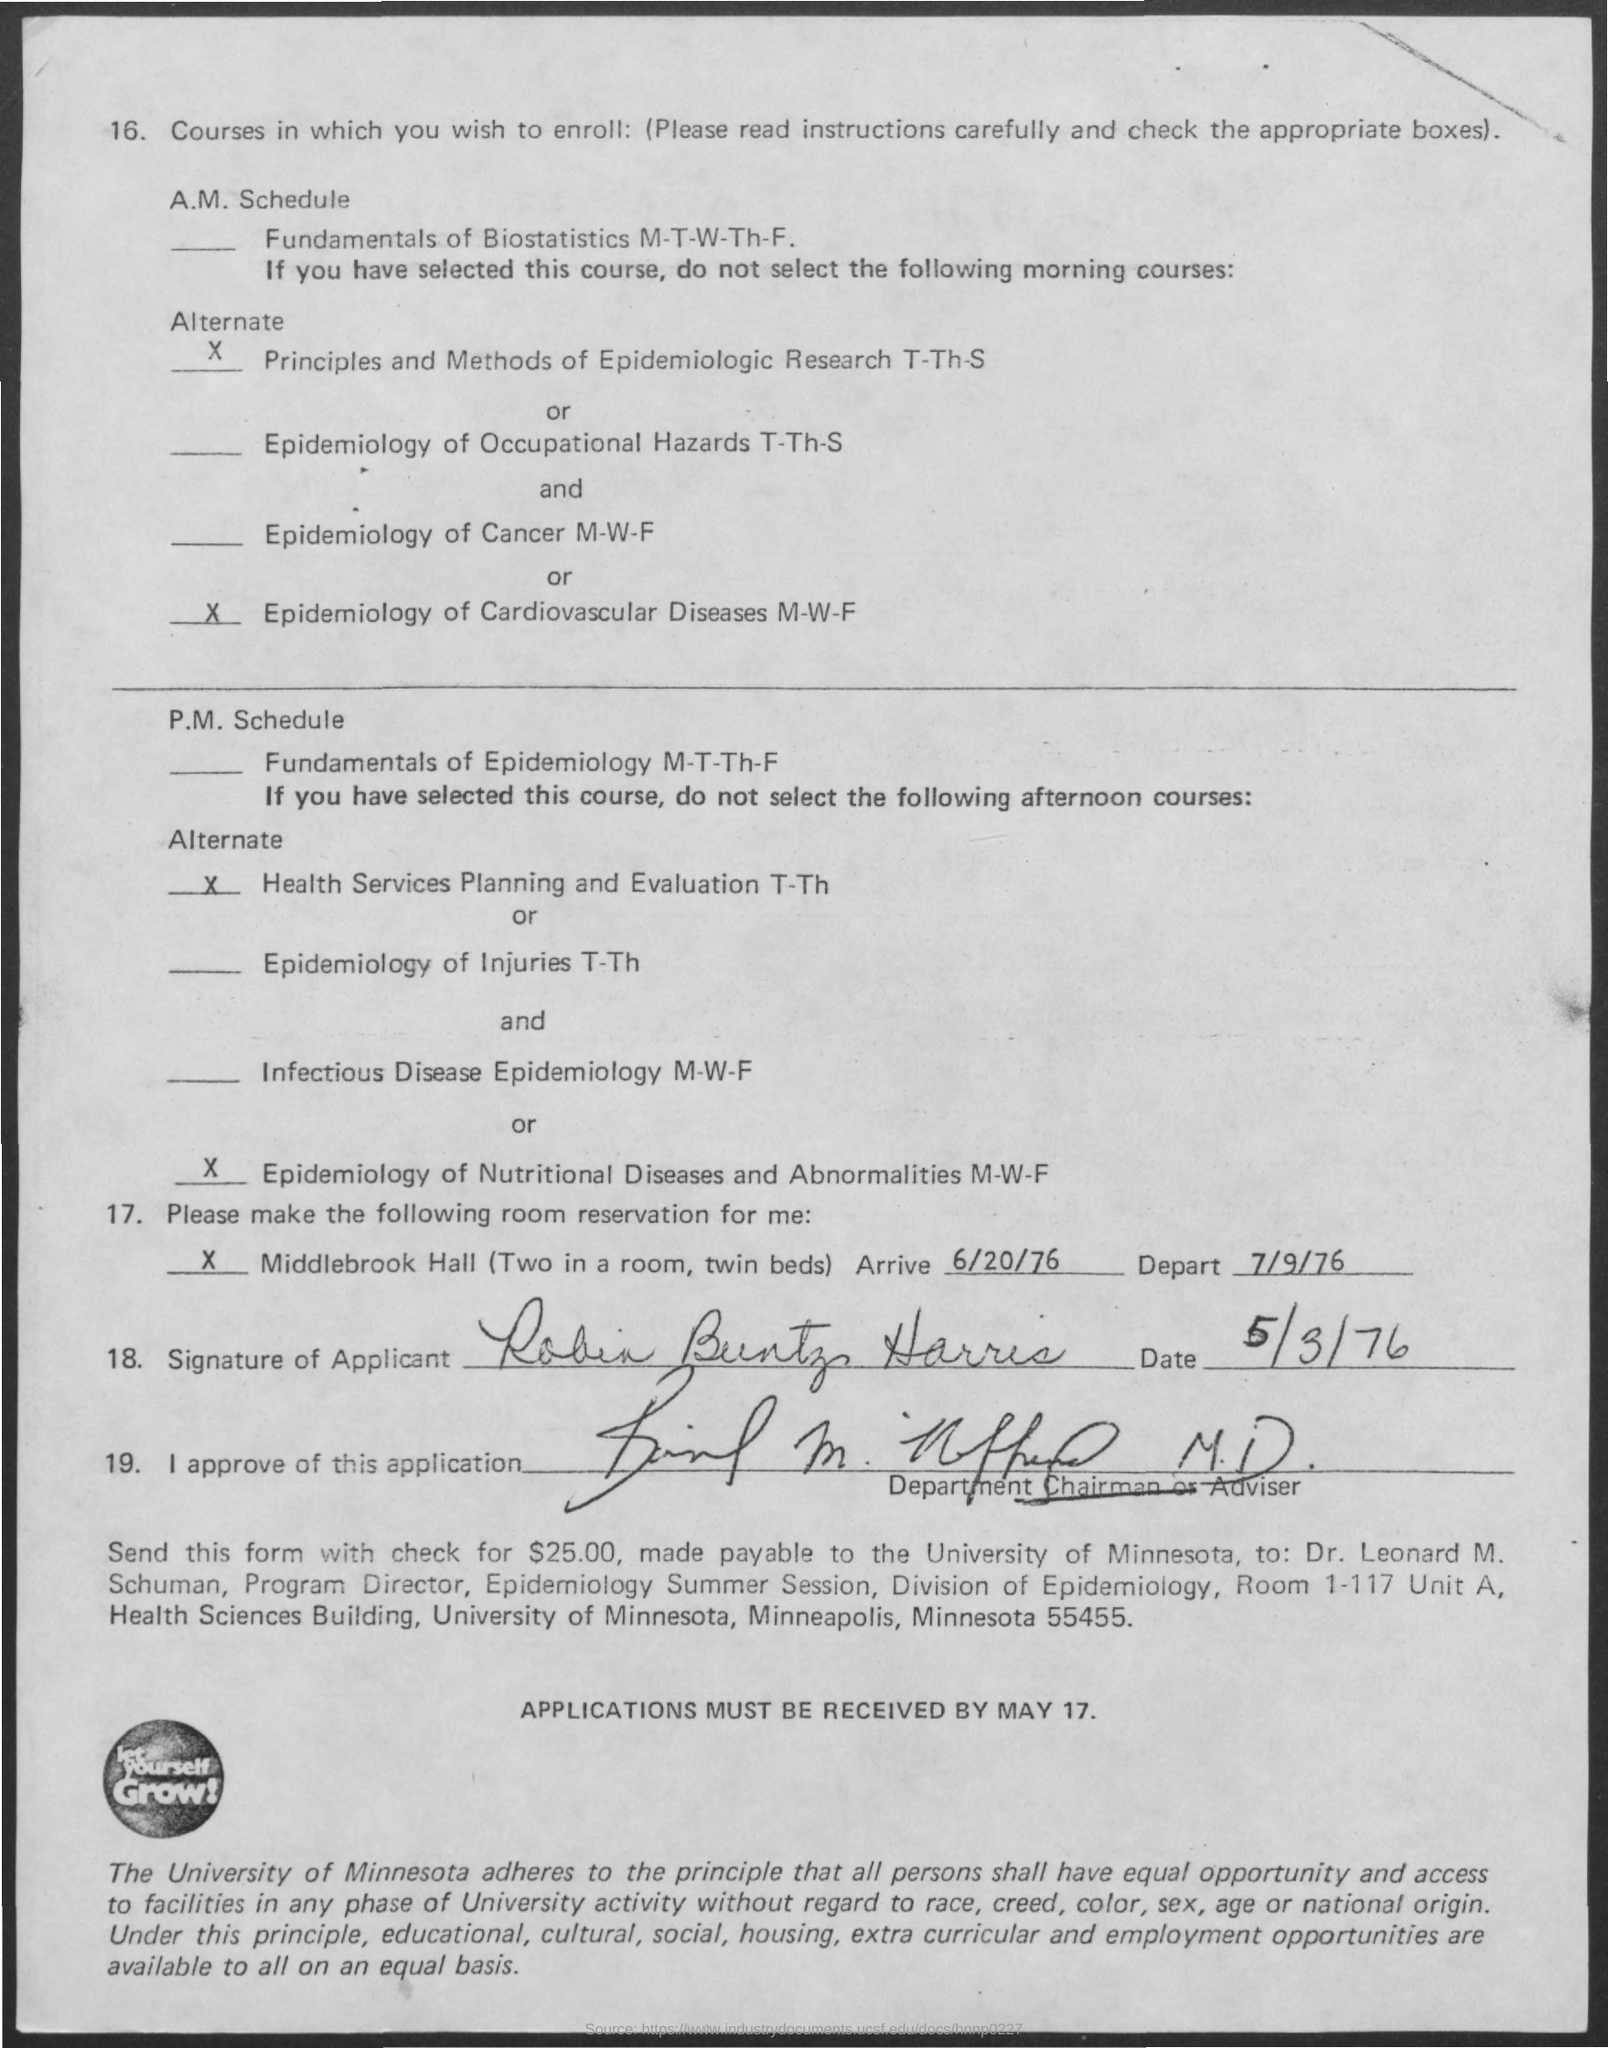Indicate a few pertinent items in this graphic. The "Depart" date is July 9, 1976. The "Arrive" date is June 20th, 1976. 